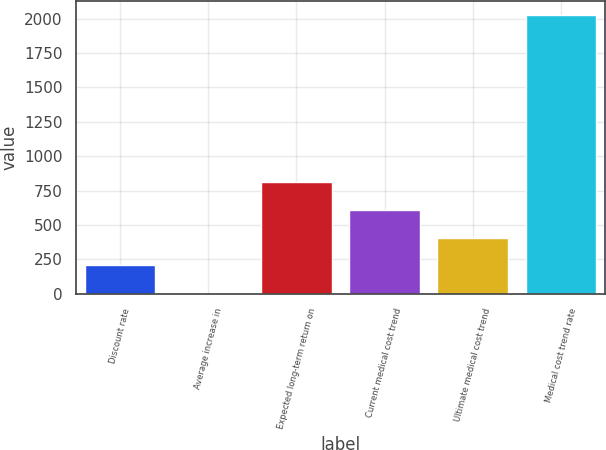<chart> <loc_0><loc_0><loc_500><loc_500><bar_chart><fcel>Discount rate<fcel>Average increase in<fcel>Expected long-term return on<fcel>Current medical cost trend<fcel>Ultimate medical cost trend<fcel>Medical cost trend rate<nl><fcel>205.6<fcel>3<fcel>813.4<fcel>610.8<fcel>408.2<fcel>2029<nl></chart> 